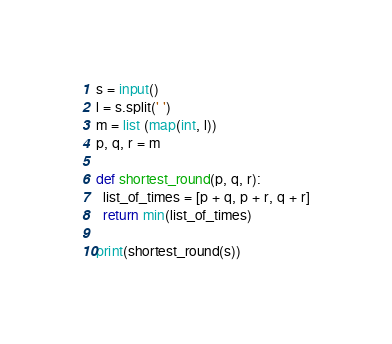<code> <loc_0><loc_0><loc_500><loc_500><_Python_>s = input()
l = s.split(' ')
m = list (map(int, l))
p, q, r = m

def shortest_round(p, q, r):
  list_of_times = [p + q, p + r, q + r]
  return min(list_of_times)

print(shortest_round(s))</code> 